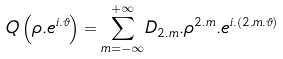Convert formula to latex. <formula><loc_0><loc_0><loc_500><loc_500>Q \left ( \rho . e ^ { i . \vartheta } \right ) = \underset { m = - \infty } { \overset { + \infty } { \sum } } D _ { 2 . m } . \rho ^ { 2 . m } . e ^ { i . ( 2 . m . \vartheta ) }</formula> 